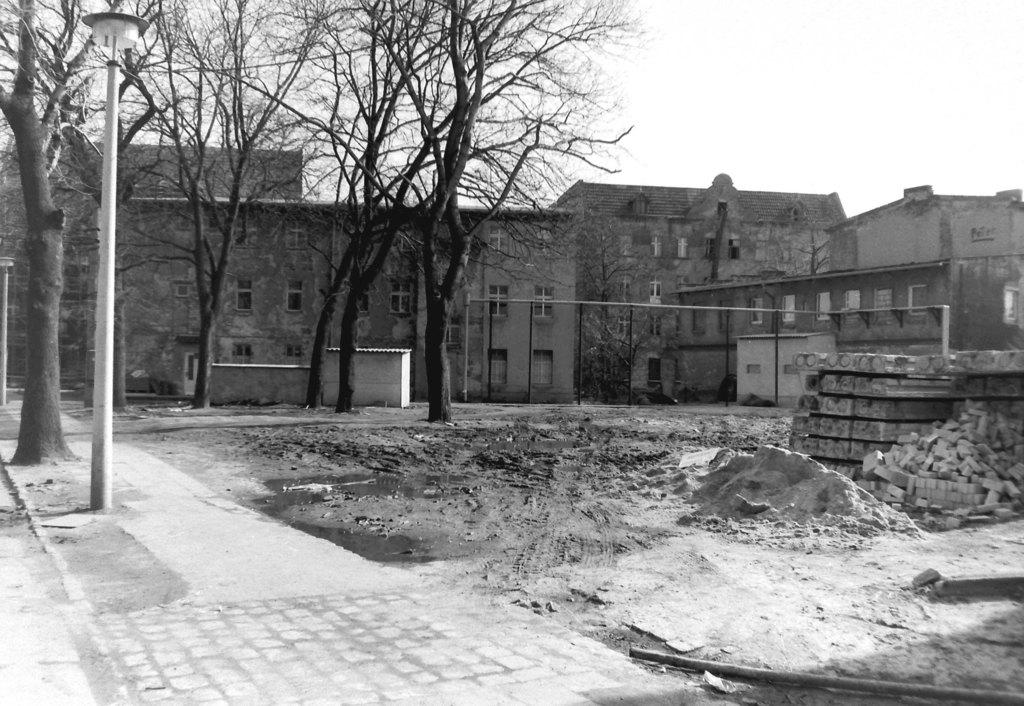What type of picture is in the image? The image contains a black and white picture. What structures can be seen in the image? There is a group of buildings and a light pole in the image. What type of vegetation is present in the image? There is a group of trees in the image. What materials are visible in the background of the image? Bricks are visible in the background of the image. What part of the natural environment is visible in the image? The sky is visible in the background of the image. What type of food is being delivered to the mailbox in the image? There is no mailbox or food present in the image. 